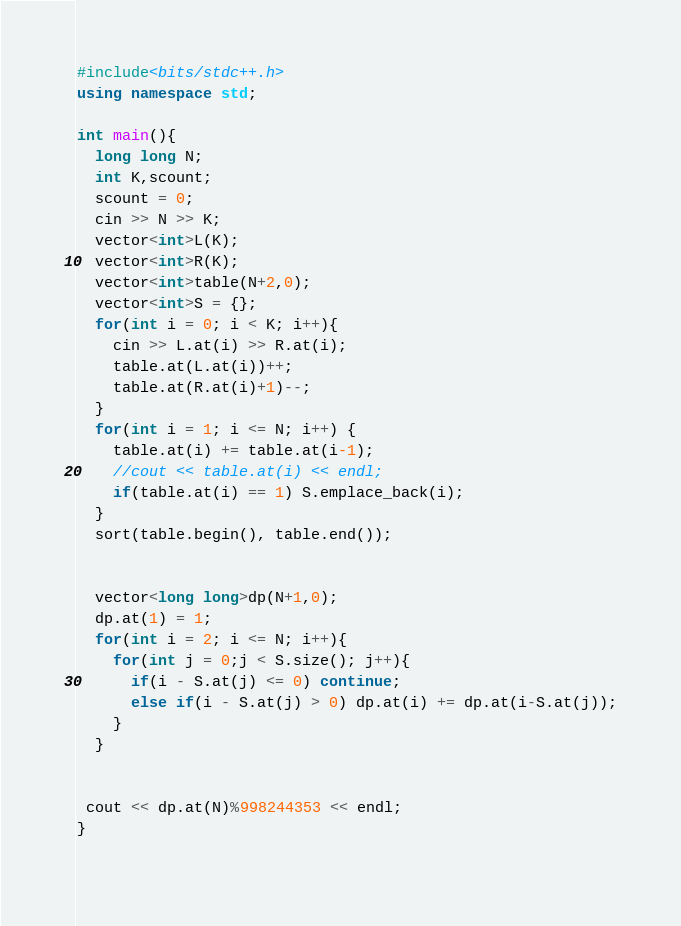Convert code to text. <code><loc_0><loc_0><loc_500><loc_500><_C++_>#include<bits/stdc++.h>
using namespace std;
 
int main(){
  long long N;
  int K,scount;
  scount = 0;
  cin >> N >> K;
  vector<int>L(K);
  vector<int>R(K);
  vector<int>table(N+2,0);
  vector<int>S = {};
  for(int i = 0; i < K; i++){
    cin >> L.at(i) >> R.at(i);
    table.at(L.at(i))++;
    table.at(R.at(i)+1)--;
  }
  for(int i = 1; i <= N; i++) {
    table.at(i) += table.at(i-1);
    //cout << table.at(i) << endl;
    if(table.at(i) == 1) S.emplace_back(i);
  }
  sort(table.begin(), table.end());
  
  
  vector<long long>dp(N+1,0);
  dp.at(1) = 1;
  for(int i = 2; i <= N; i++){
    for(int j = 0;j < S.size(); j++){
      if(i - S.at(j) <= 0) continue;
      else if(i - S.at(j) > 0) dp.at(i) += dp.at(i-S.at(j));
    }
  }
  
  
 cout << dp.at(N)%998244353 << endl;
}
  
</code> 